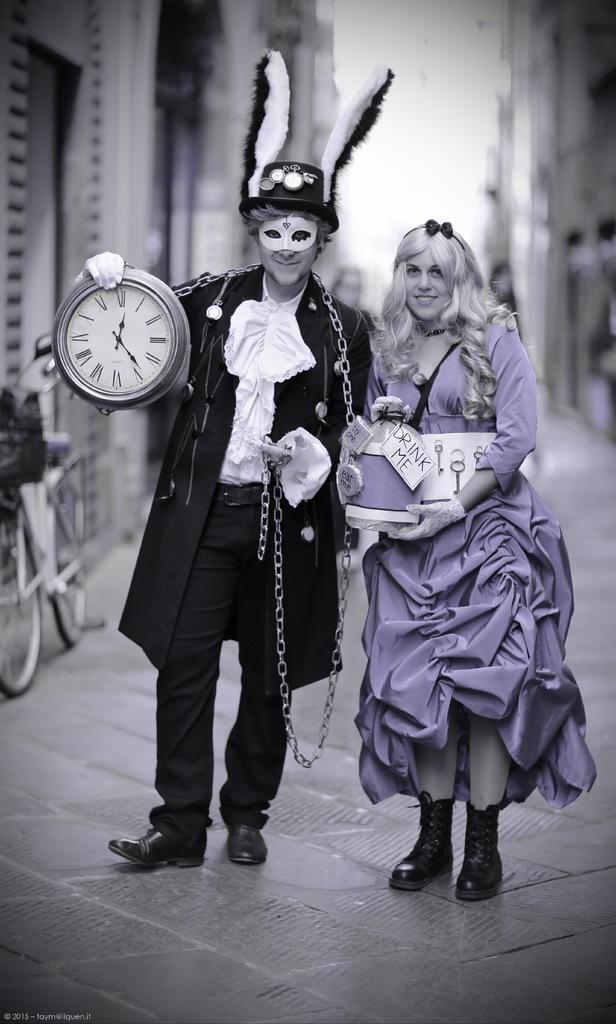Provide a one-sentence caption for the provided image. An alice and rabbit cosplay with a sign saying Drink Me. 